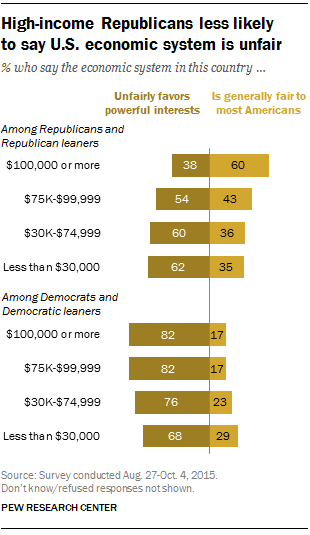Point out several critical features in this image. The value of the first leftmost bar from the top is 38. There are two brown bars that have similar values. 